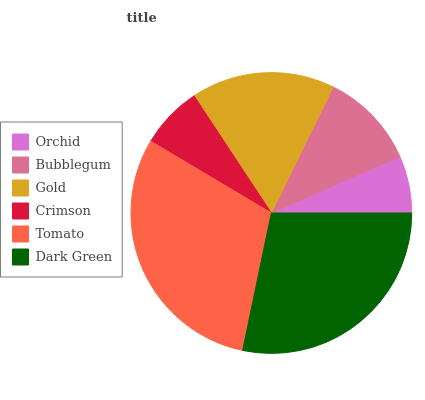Is Orchid the minimum?
Answer yes or no. Yes. Is Tomato the maximum?
Answer yes or no. Yes. Is Bubblegum the minimum?
Answer yes or no. No. Is Bubblegum the maximum?
Answer yes or no. No. Is Bubblegum greater than Orchid?
Answer yes or no. Yes. Is Orchid less than Bubblegum?
Answer yes or no. Yes. Is Orchid greater than Bubblegum?
Answer yes or no. No. Is Bubblegum less than Orchid?
Answer yes or no. No. Is Gold the high median?
Answer yes or no. Yes. Is Bubblegum the low median?
Answer yes or no. Yes. Is Dark Green the high median?
Answer yes or no. No. Is Orchid the low median?
Answer yes or no. No. 